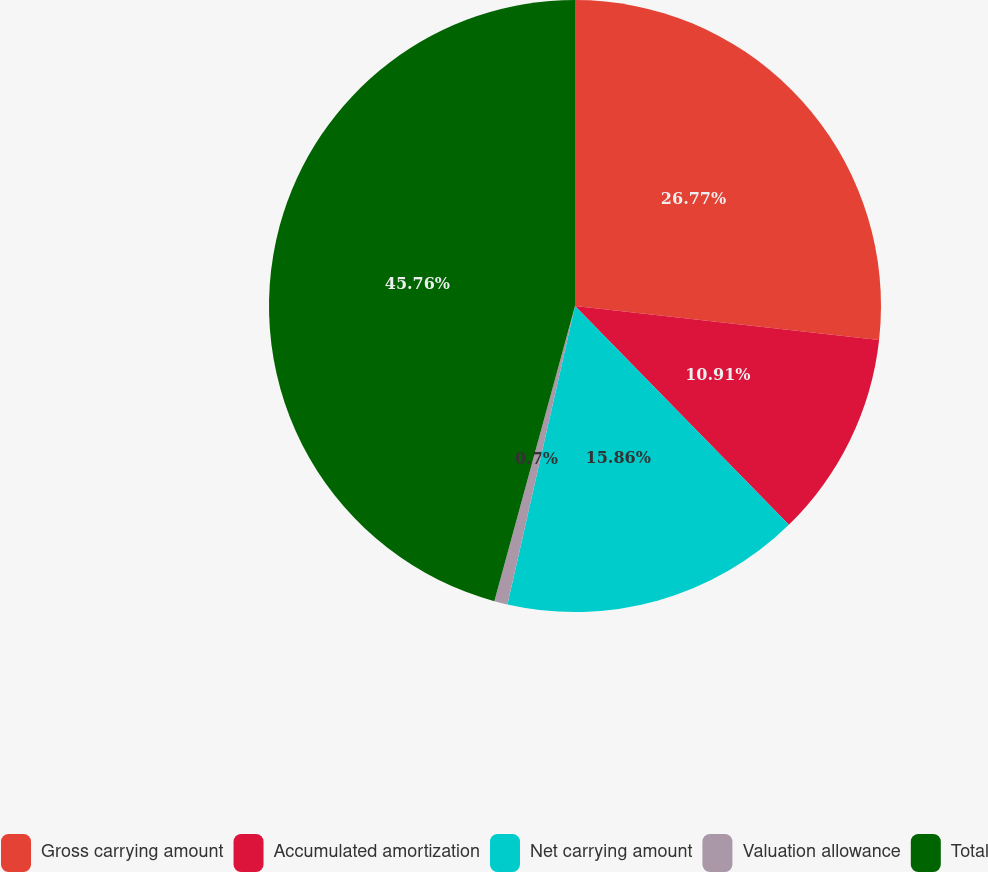<chart> <loc_0><loc_0><loc_500><loc_500><pie_chart><fcel>Gross carrying amount<fcel>Accumulated amortization<fcel>Net carrying amount<fcel>Valuation allowance<fcel>Total<nl><fcel>26.77%<fcel>10.91%<fcel>15.86%<fcel>0.7%<fcel>45.75%<nl></chart> 